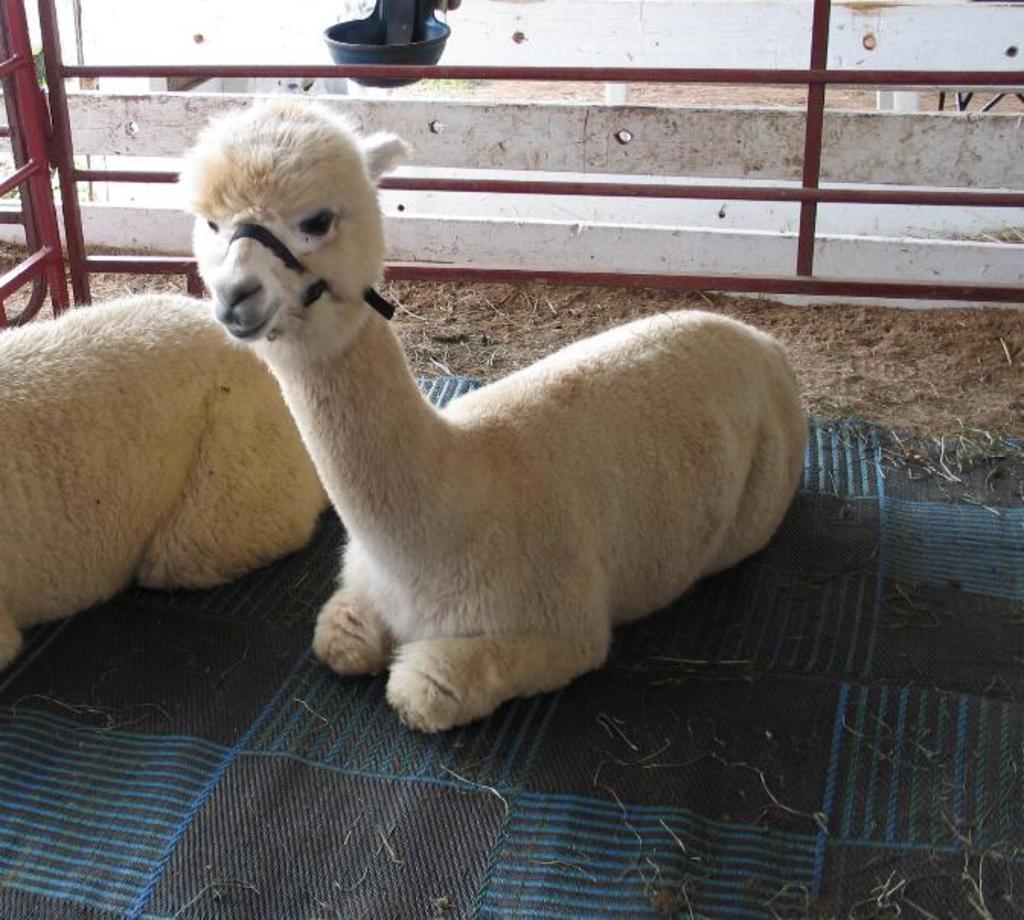In one or two sentences, can you explain what this image depicts? In this picture there are animals on cloth and we can see fence and bowl. 